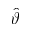Convert formula to latex. <formula><loc_0><loc_0><loc_500><loc_500>\hat { \vartheta }</formula> 